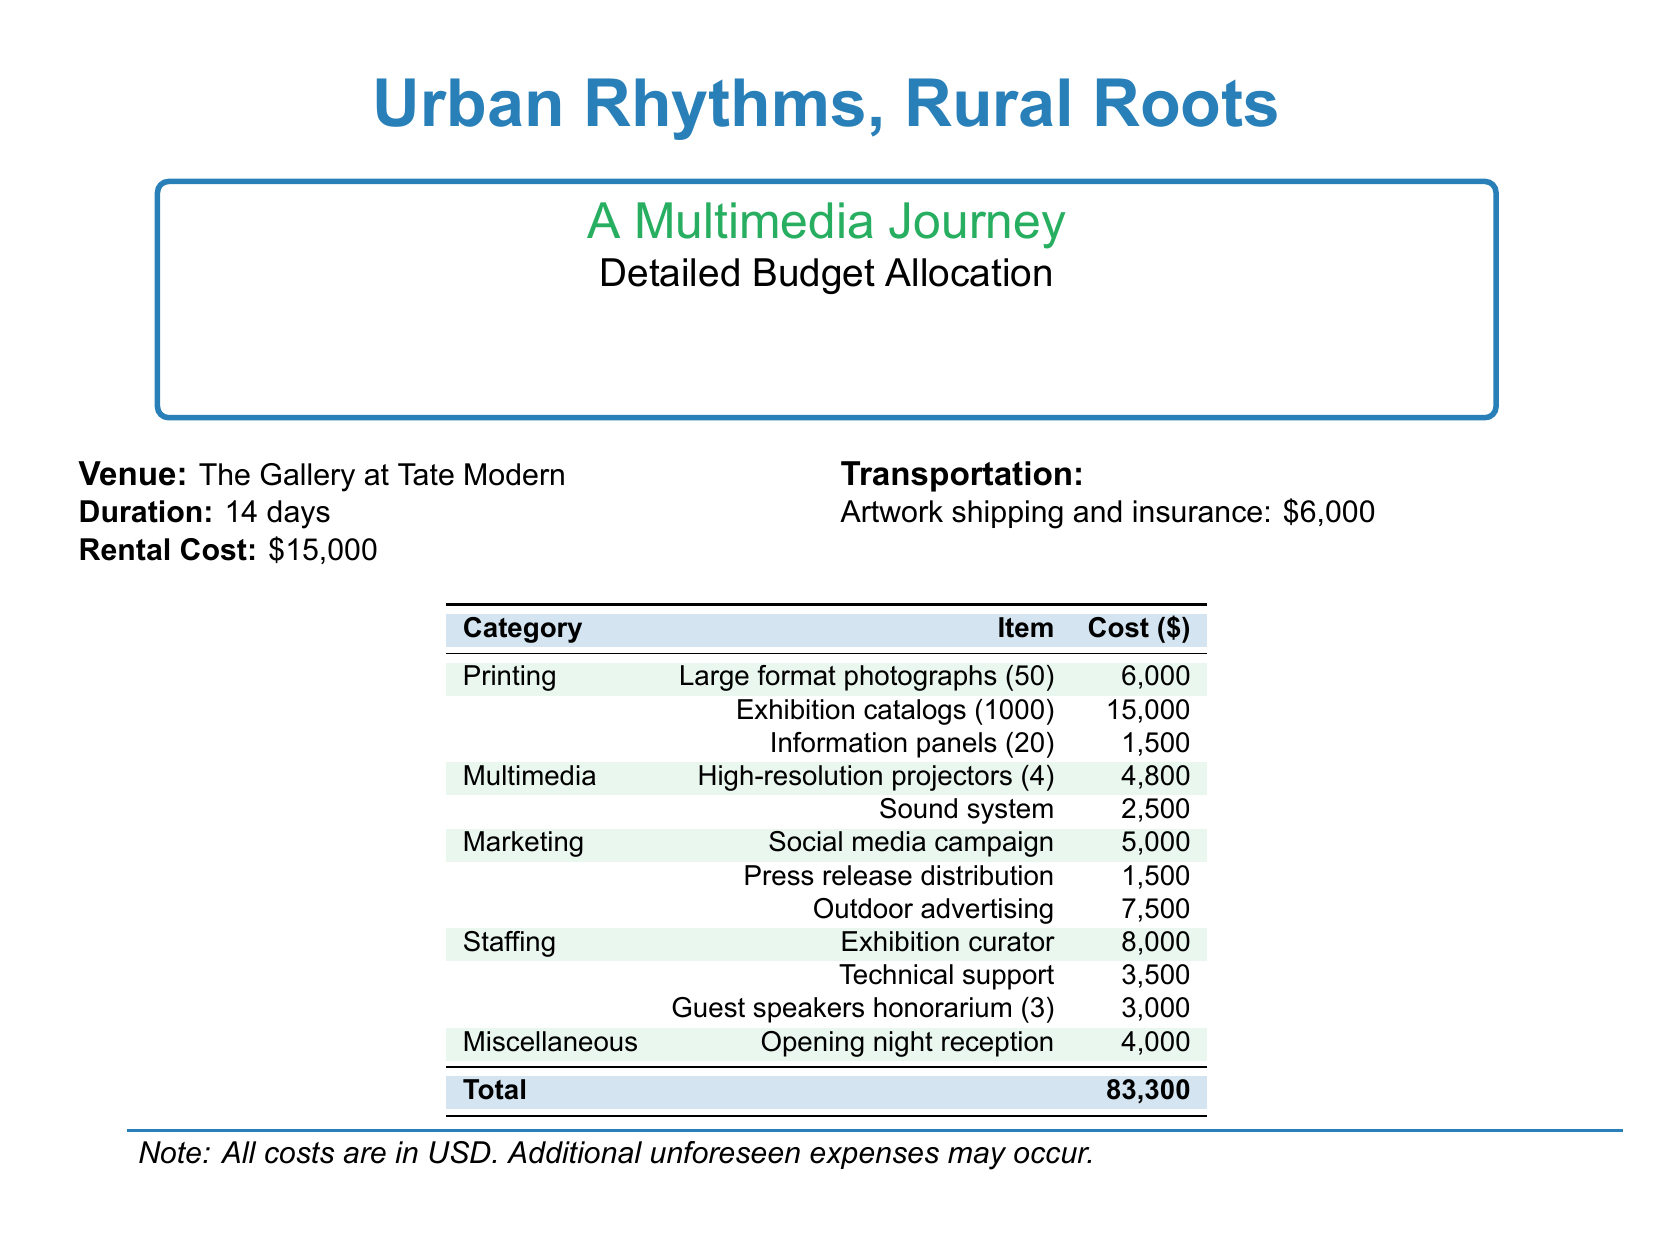What is the venue for the exhibition? The venue for the exhibition is specified in the document as "The Gallery at Tate Modern."
Answer: The Gallery at Tate Modern What is the rental cost of the venue? The rental cost is given clearly in the document as $15,000.
Answer: $15,000 How many large format photographs will be printed? The document states that there will be 50 large format photographs printed.
Answer: 50 What is the total budget for the exhibition? The total budget is calculated at the bottom of the document as $83,300.
Answer: $83,300 How much will be spent on social media marketing? The amount designated for the social media campaign is noted as $5,000.
Answer: $5,000 How many high-resolution projectors will be used? The number of high-resolution projectors is mentioned as 4 in the budget document.
Answer: 4 What is the cost of the opening night reception? The cost for the opening night reception is listed as $4,000.
Answer: $4,000 What is the honorarium for guest speakers? The document indicates that the honorarium for guest speakers is $3,000.
Answer: $3,000 What is the transportation cost for artwork shipping and insurance? The document specifies the transportation cost as $6,000 for artwork shipping and insurance.
Answer: $6,000 